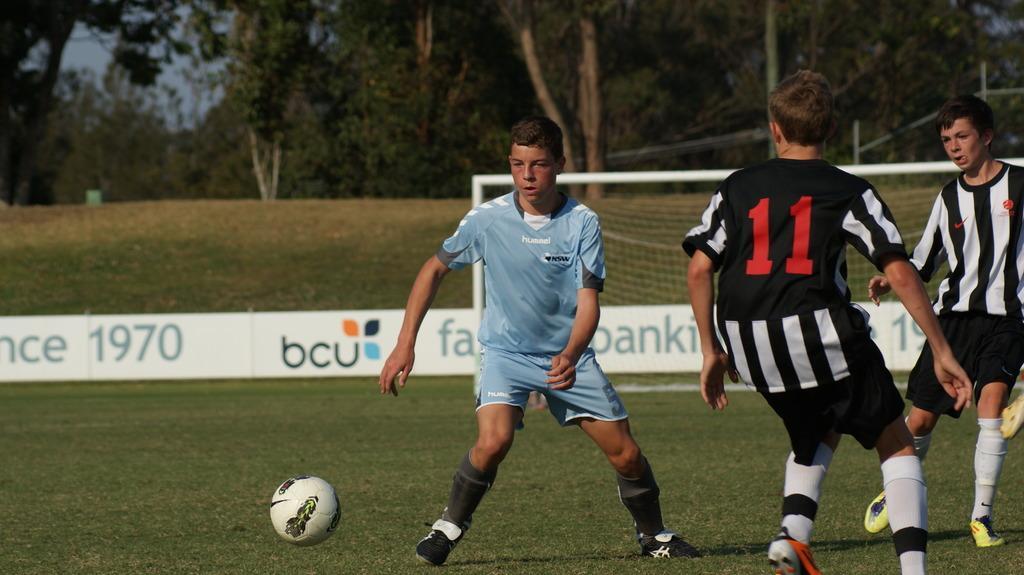How would you summarize this image in a sentence or two? In this image I can see people playing football. There is a goal court behind them. There is grass and trees at the back. 